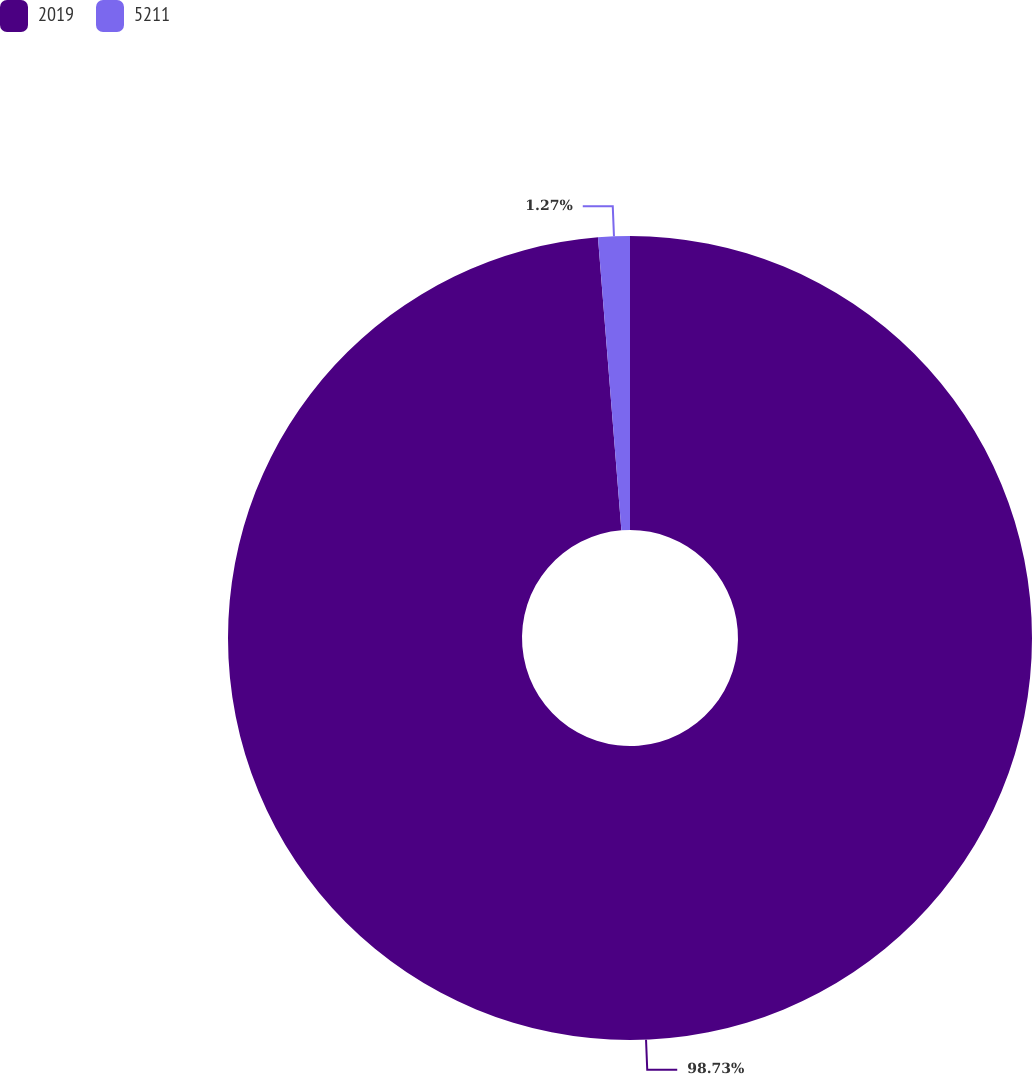Convert chart. <chart><loc_0><loc_0><loc_500><loc_500><pie_chart><fcel>2019<fcel>5211<nl><fcel>98.73%<fcel>1.27%<nl></chart> 